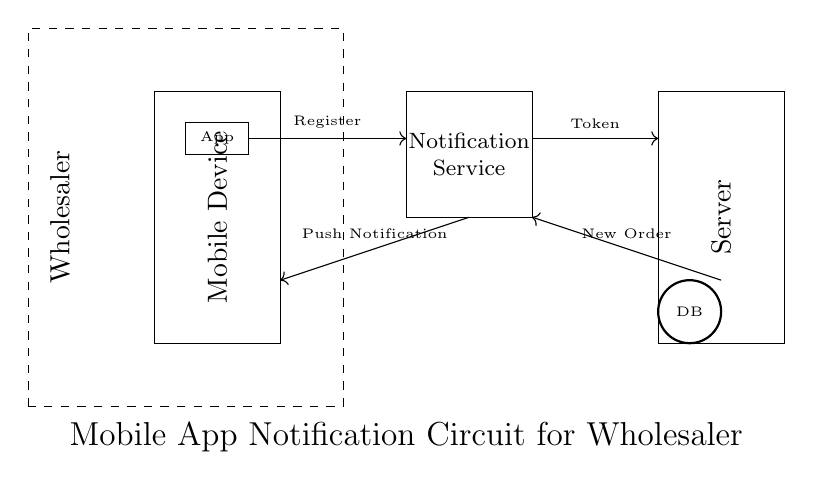What is the main component representing the wholesaler? The wholesaler is represented by a dashed rectangle that encompasses the circuits. This signifies that the wholesaler is involved in the overall process but isn't a direct component of the circuit's functionality.
Answer: Wholesaler How does the app communicate with the notification service? The app sends a registration signal to the notification service, indicated by the direction of the arrow connecting the app and the service. This shows the flow of data from the app to the service.
Answer: Register What type of data is sent from the server to the notification service? The server sends a token, which is indicated by the arrow labeled "Token" between the notification service and the server. This is essential for the notification process to validate the push notifications.
Answer: Token What is the purpose of the database in this circuit? The database serves as a storage component, indicated by the circle labeled "DB." It holds relevant information needed for order processing and notifications, allowing for efficient data retrieval and management.
Answer: Data storage What type of notification is sent to the wholesaler? A push notification is sent, as shown by the arrow labeled "Push Notification" from the notification service to the wholesaler's app interface. This signifies the communication method used to inform the wholesaler of new orders.
Answer: Push Notification What does the arrow labeled "New Order" represent in this context? The "New Order" arrow indicates the flow of information from the server to the notification service, showing that the server sends a signal identifying a new order that needs to be processed and notified.
Answer: New Order 